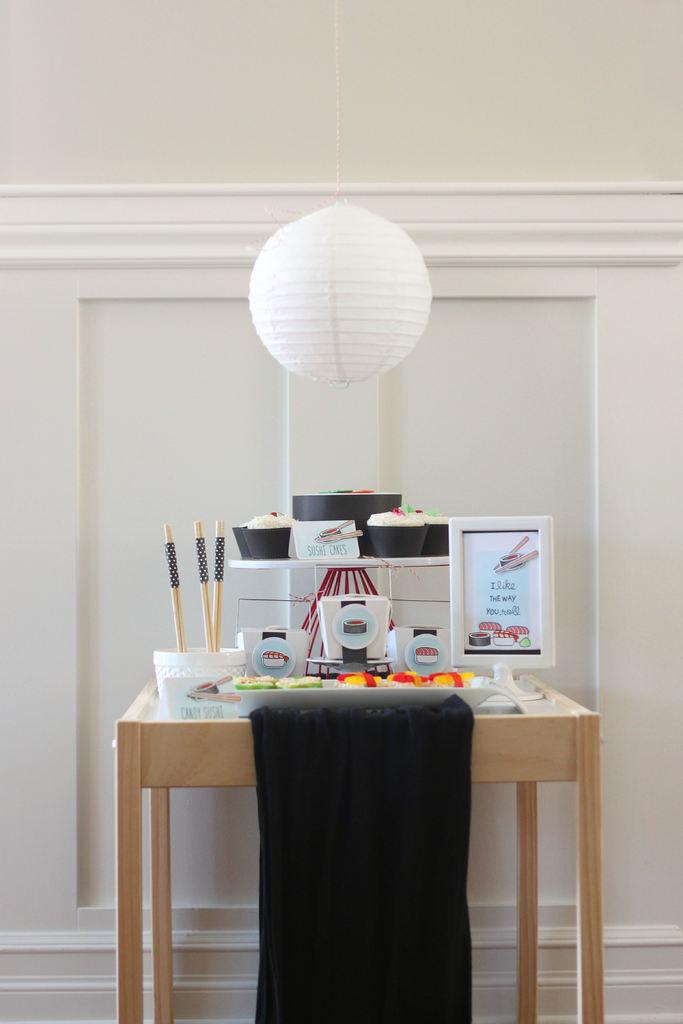<image>
Give a short and clear explanation of the subsequent image. A tray of sushi is on a small table with an electronic ordering system that displays "I like the way you roll". 